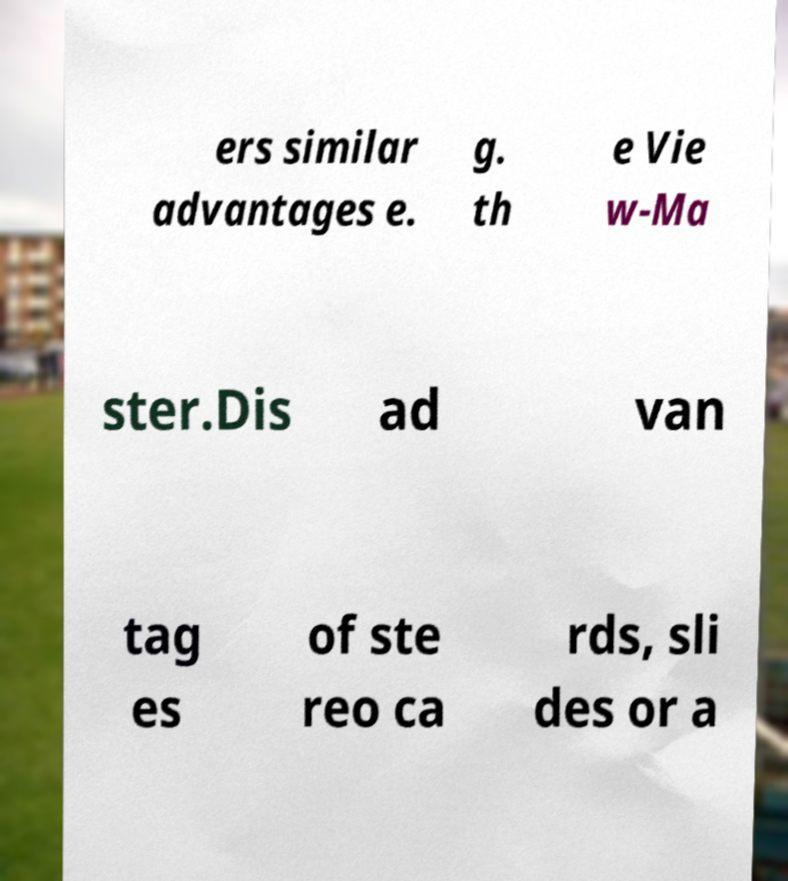Can you read and provide the text displayed in the image?This photo seems to have some interesting text. Can you extract and type it out for me? ers similar advantages e. g. th e Vie w-Ma ster.Dis ad van tag es of ste reo ca rds, sli des or a 